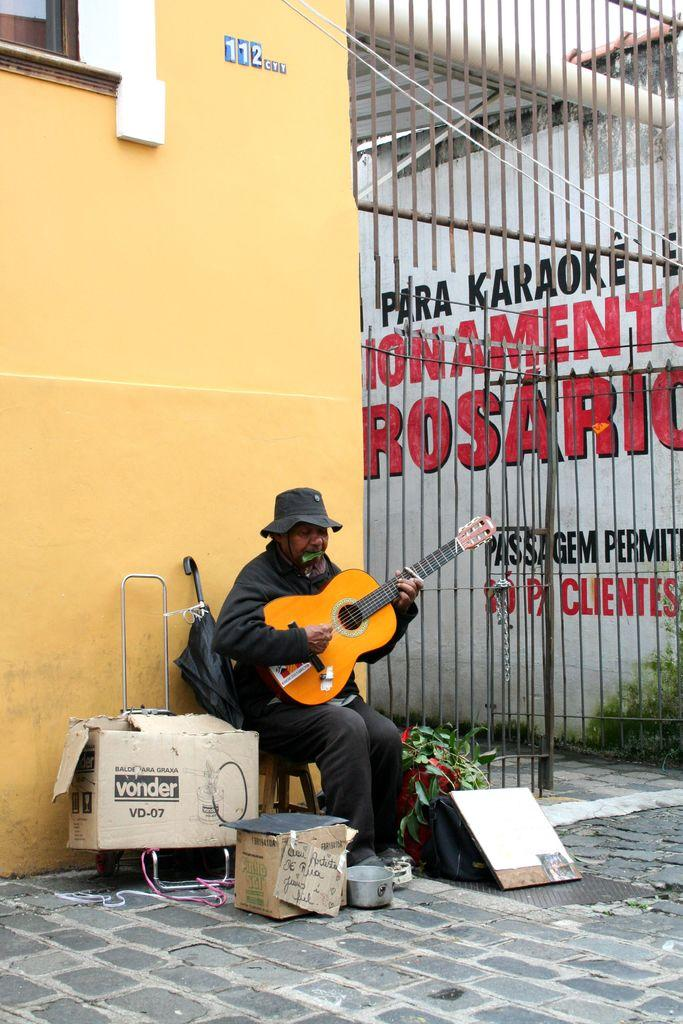Who is the person in the image? There is a man in the image. What is the man doing in the image? The man is sitting on a chair and playing the guitar. What can be seen on the right side of the image? There is an iron gate on the right side of the image. What type of sheet is the man using to teach the guitar in the image? There is no sheet present in the image, and the man is not teaching the guitar; he is playing it. 